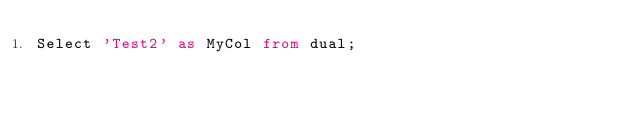Convert code to text. <code><loc_0><loc_0><loc_500><loc_500><_SQL_>Select 'Test2' as MyCol from dual;</code> 